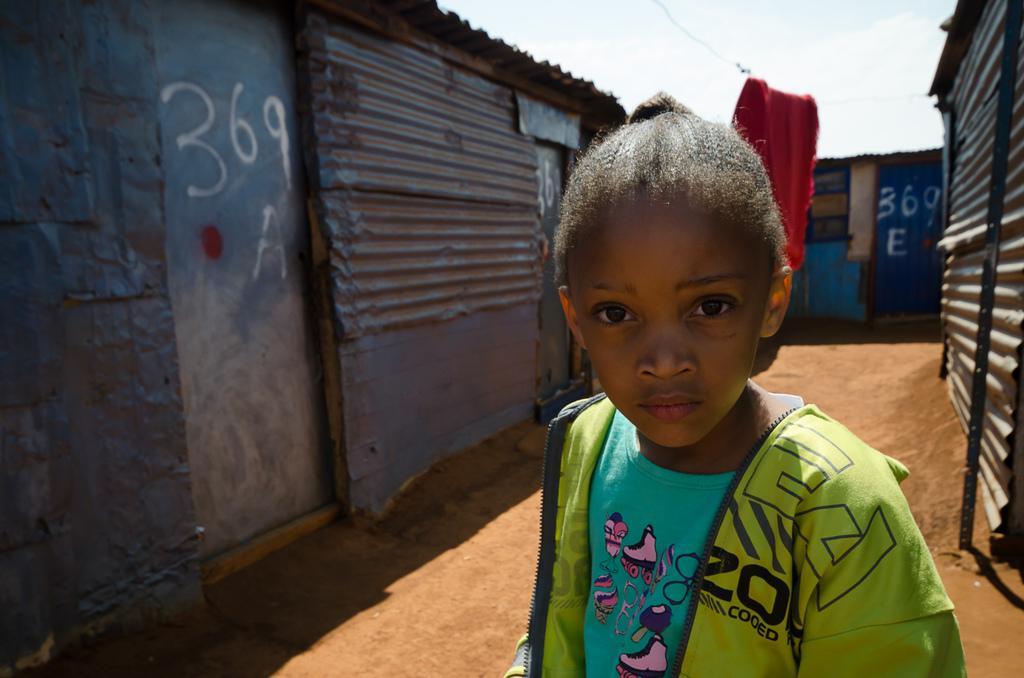Can you describe this image briefly? In the center of the image, we can see a kid wearing a coat and in the background, there are sheds and we can see some text on the doors and there is a cloth hanging on the rope. At the top, there is sky and at the bottom, there is ground. 